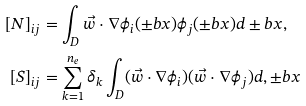Convert formula to latex. <formula><loc_0><loc_0><loc_500><loc_500>[ N ] _ { i j } & = \int _ { D } \vec { w } \cdot \nabla \phi _ { i } ( \pm b { x } ) \phi _ { j } ( \pm b { x } ) d \pm b { x } , \\ [ S ] _ { i j } & = \sum _ { k = 1 } ^ { n _ { e } } \delta _ { k } \int _ { D } ( \vec { w } \cdot \nabla \phi _ { i } ) ( \vec { w } \cdot \nabla \phi _ { j } ) d , \pm b { x }</formula> 